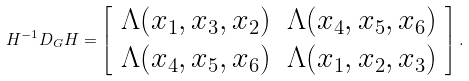Convert formula to latex. <formula><loc_0><loc_0><loc_500><loc_500>H ^ { - 1 } D _ { G } H = \left [ \begin{array} { c c } \Lambda ( x _ { 1 } , x _ { 3 } , x _ { 2 } ) & \Lambda ( x _ { 4 } , x _ { 5 } , x _ { 6 } ) \\ \Lambda ( x _ { 4 } , x _ { 5 } , x _ { 6 } ) & \Lambda ( x _ { 1 } , x _ { 2 } , x _ { 3 } ) \end{array} \right ] .</formula> 